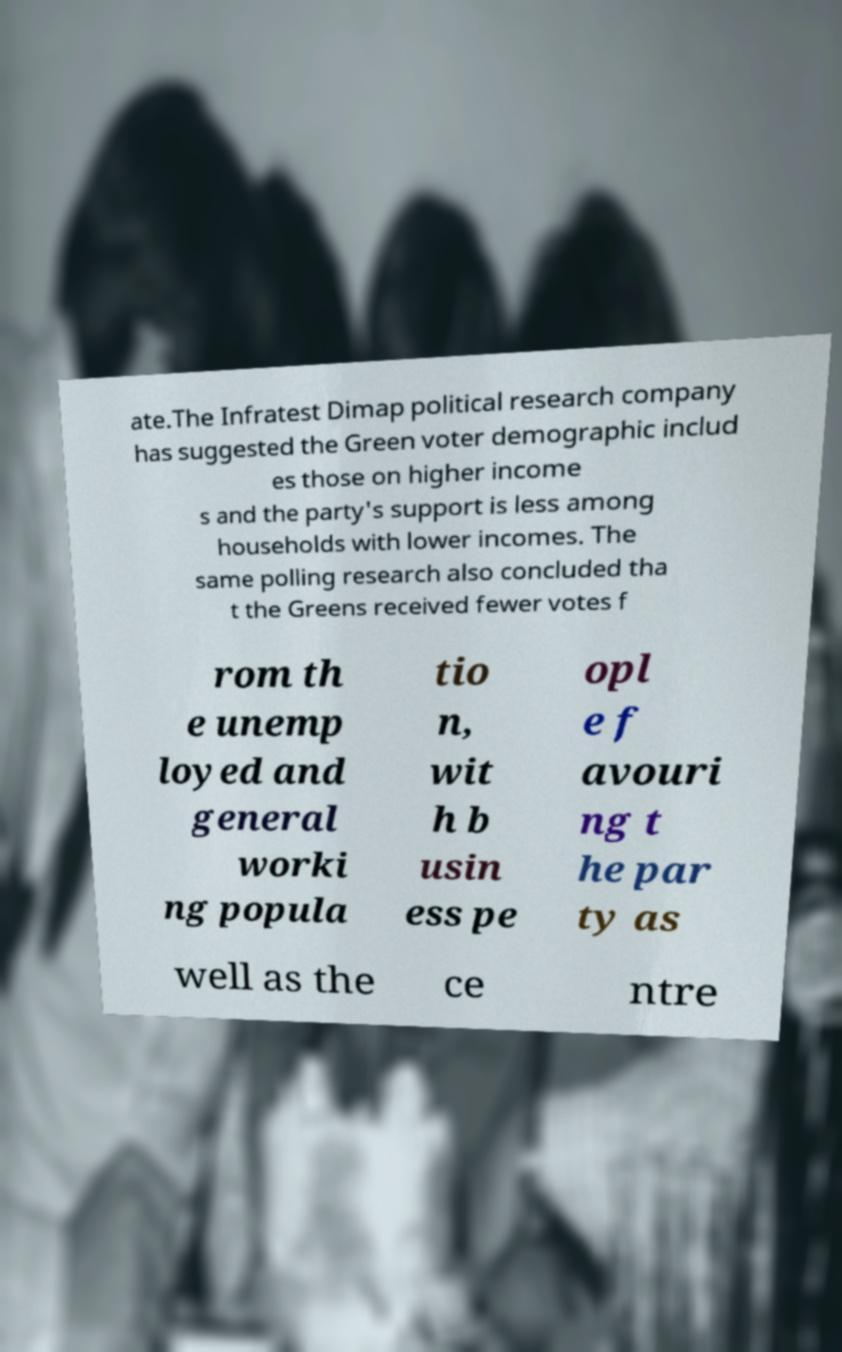Please identify and transcribe the text found in this image. ate.The Infratest Dimap political research company has suggested the Green voter demographic includ es those on higher income s and the party's support is less among households with lower incomes. The same polling research also concluded tha t the Greens received fewer votes f rom th e unemp loyed and general worki ng popula tio n, wit h b usin ess pe opl e f avouri ng t he par ty as well as the ce ntre 